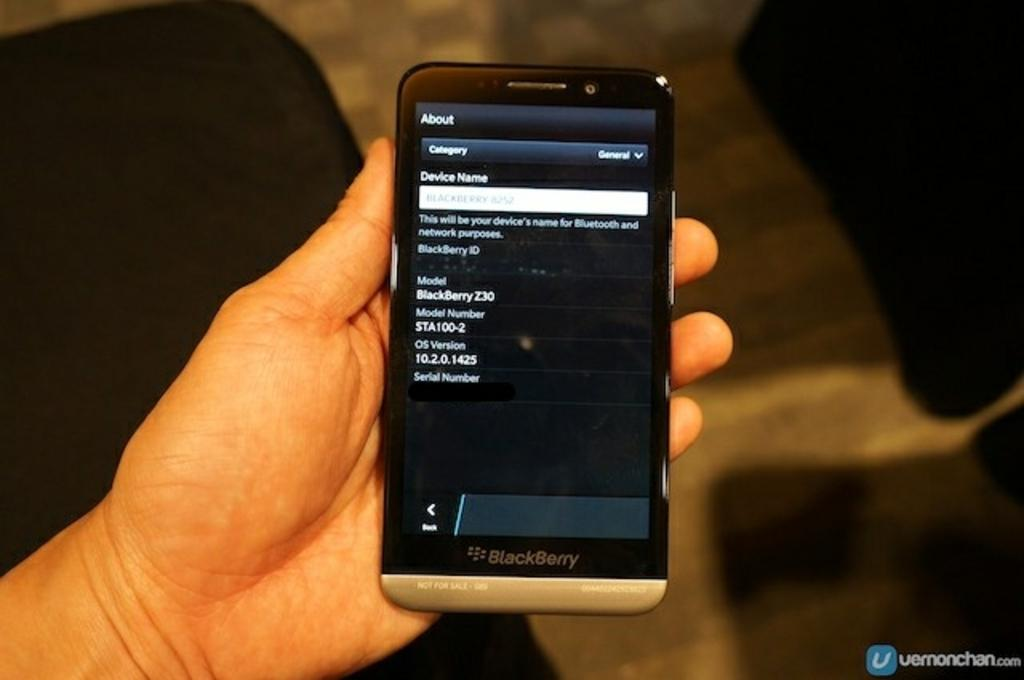<image>
Describe the image concisely. a phone that has an about section on top of the screen 